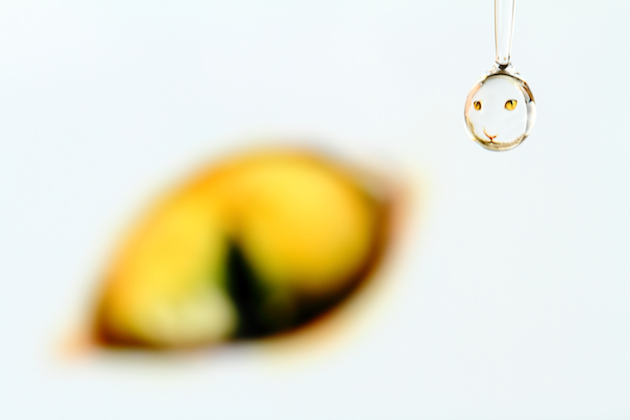Can you explain how the smiley face effect is achieved in this water droplet? The smiley face inside the water droplet is created through the optical phenomenon of refraction. When light passes through the water droplet, it bends and distorts the image behind it. Here, the photographer has cleverly positioned the droplet against a background with a smiley pattern. The curve of the droplet acts like a lens, flipping the image and reducing its size to fit within the droplet, thus creating this delightful visual effect. 